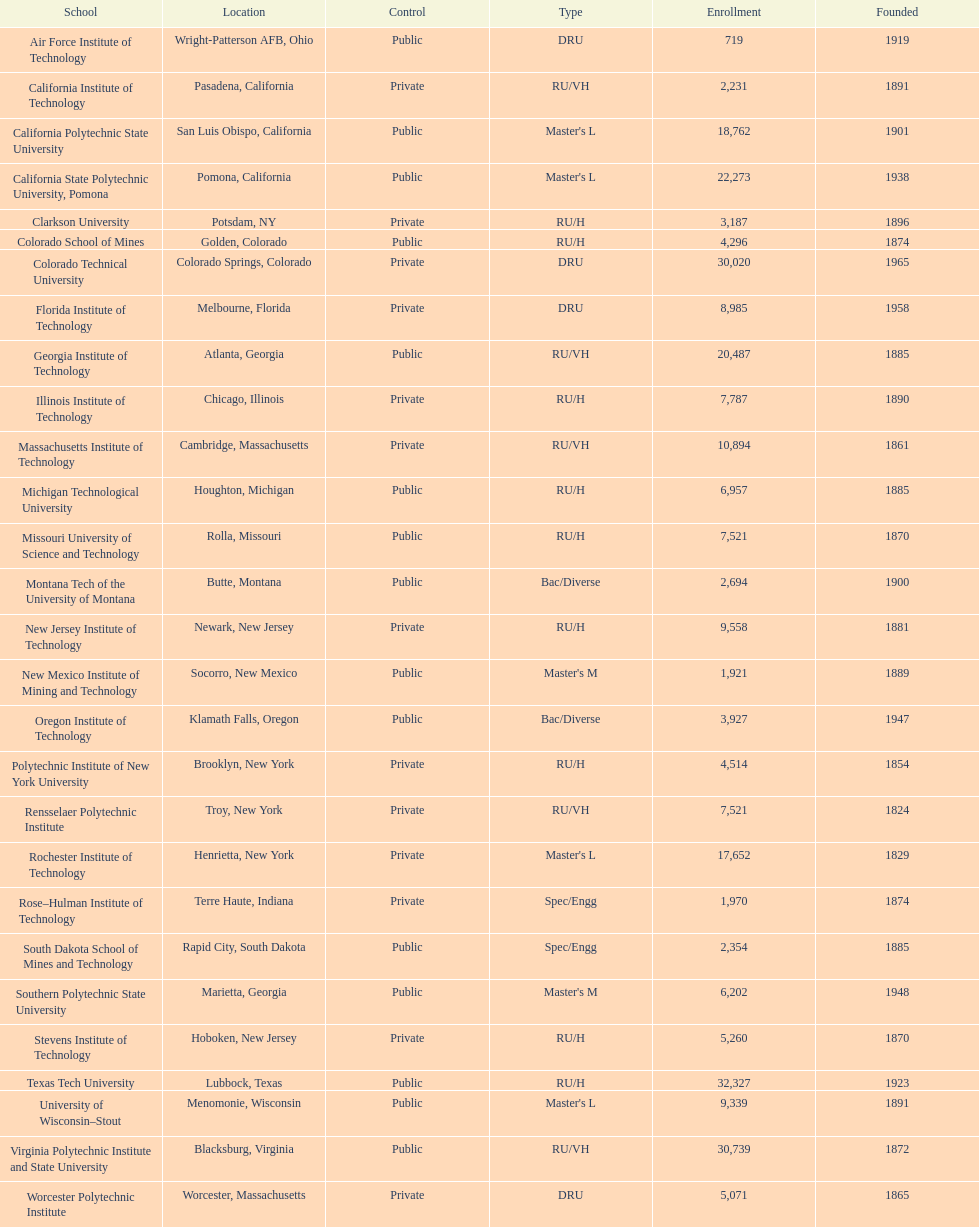What is the quantity of schools displayed in the table? 28. 